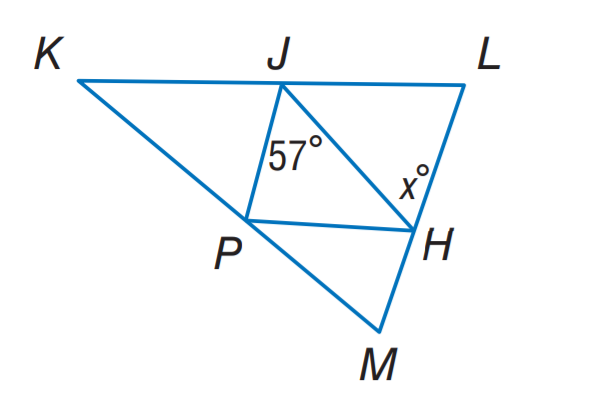Question: J H, J P, and P H are midsegments of \triangle K L M. Find x.
Choices:
A. 37
B. 47
C. 57
D. 67
Answer with the letter. Answer: C 